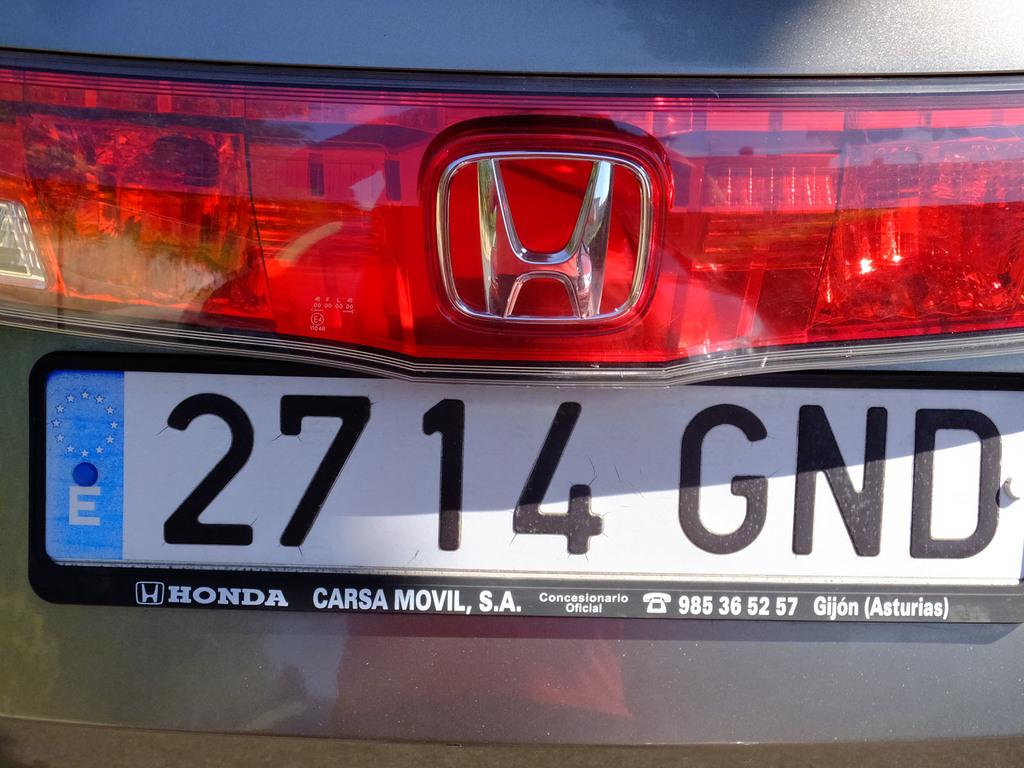What brand is the car?
Your response must be concise. Honda. Where is the car from?
Make the answer very short. Carsa movil, s.a. 